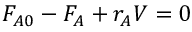Convert formula to latex. <formula><loc_0><loc_0><loc_500><loc_500>F _ { A 0 } - F _ { A } + r _ { A } V = 0</formula> 